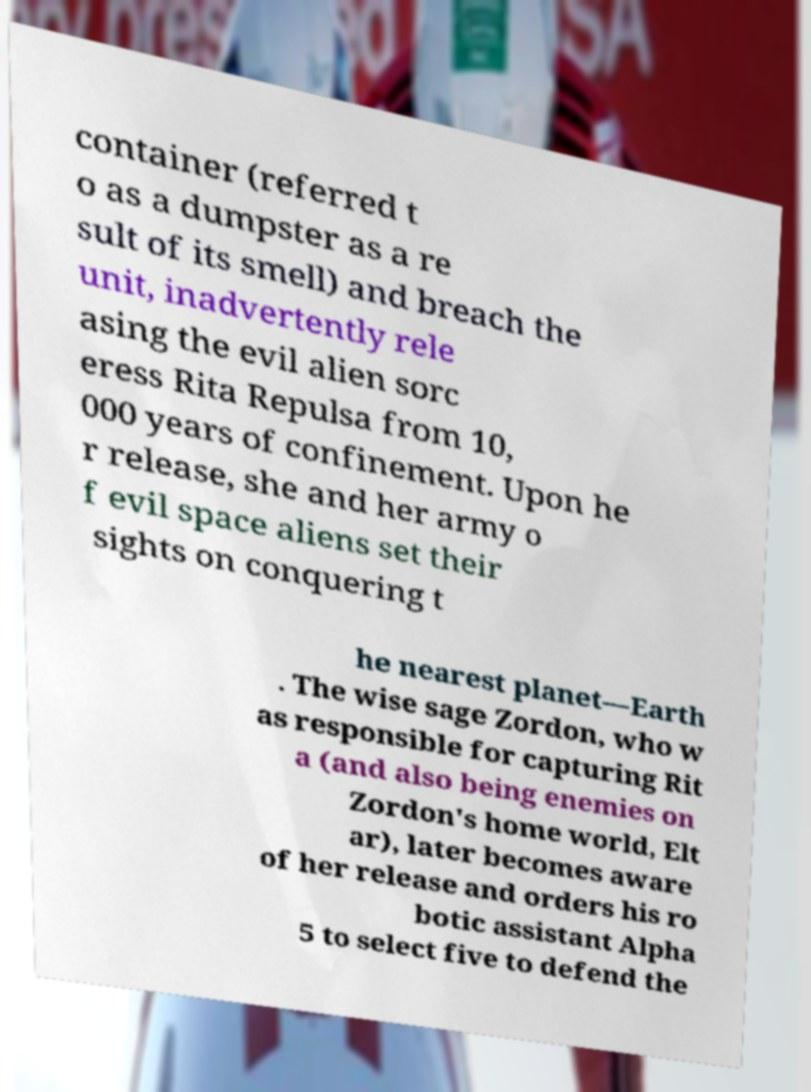For documentation purposes, I need the text within this image transcribed. Could you provide that? container (referred t o as a dumpster as a re sult of its smell) and breach the unit, inadvertently rele asing the evil alien sorc eress Rita Repulsa from 10, 000 years of confinement. Upon he r release, she and her army o f evil space aliens set their sights on conquering t he nearest planet—Earth . The wise sage Zordon, who w as responsible for capturing Rit a (and also being enemies on Zordon's home world, Elt ar), later becomes aware of her release and orders his ro botic assistant Alpha 5 to select five to defend the 